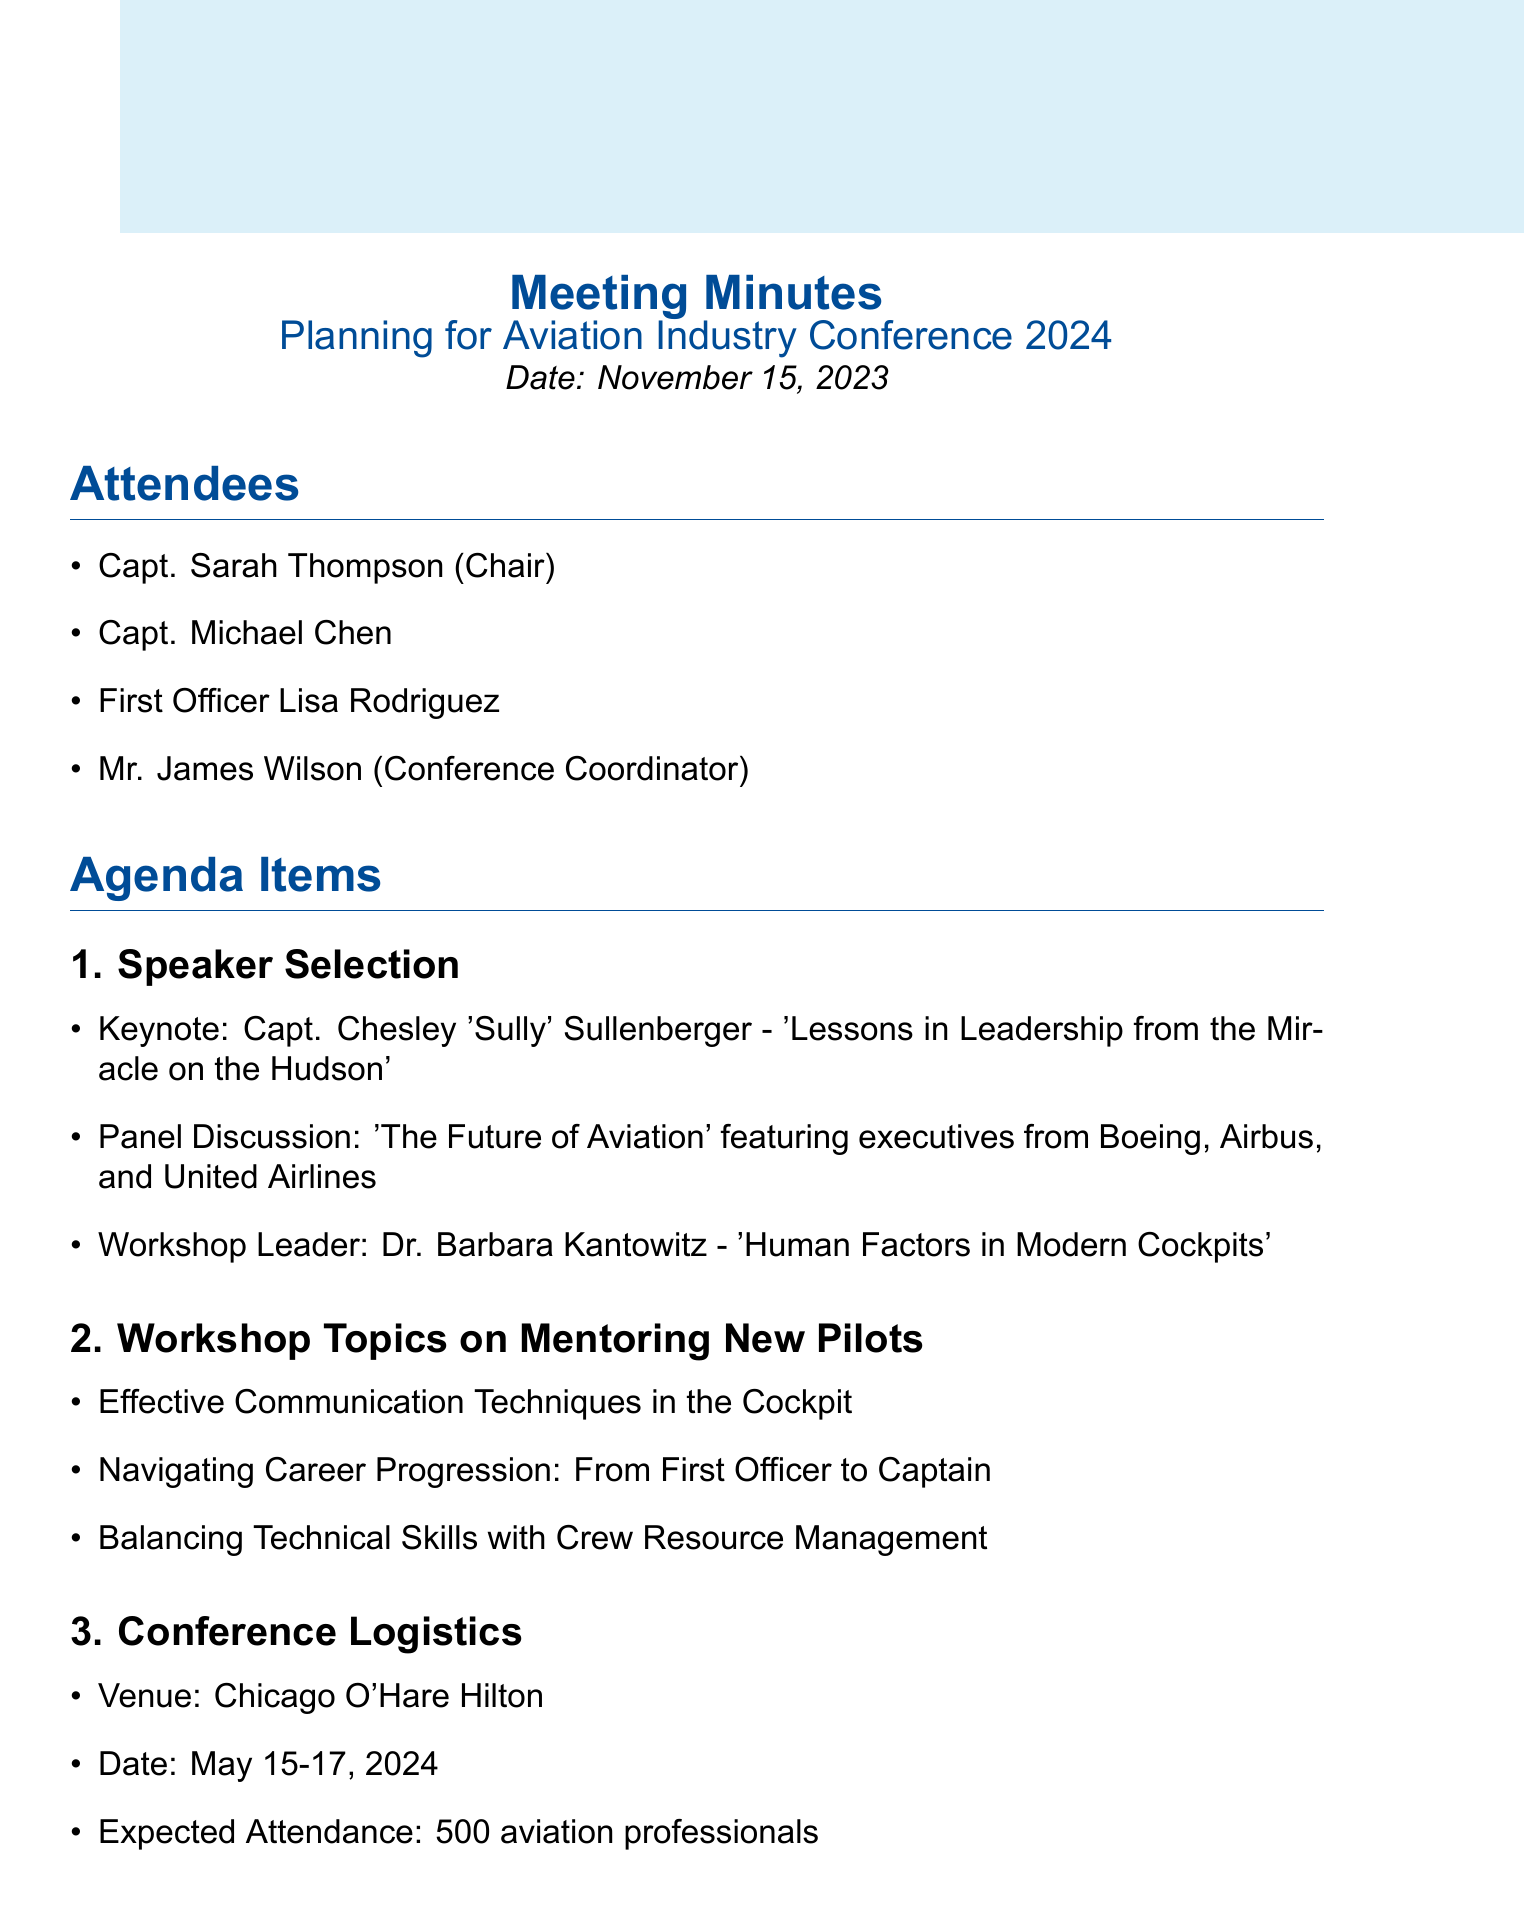What is the title of the meeting? The title of the meeting is stated in the document as "Planning for Aviation Industry Conference 2024."
Answer: Planning for Aviation Industry Conference 2024 Who is the keynote speaker? The keynote speaker is mentioned in the speaker selection section of the document as Capt. Chesley 'Sully' Sullenberger.
Answer: Capt. Chesley 'Sully' Sullenberger What are the dates of the conference? The dates of the conference are specified in the logistics section of the document as May 15-17, 2024.
Answer: May 15-17, 2024 How many expected attendees are there? The expected attendance is a specific detail found under conference logistics, stating the number of aviation professionals expected.
Answer: 500 aviation professionals What is the venue for the conference? The venue of the conference is listed in the conference logistics section as Chicago O'Hare Hilton.
Answer: Chicago O'Hare Hilton What workshop topic addresses communication techniques? The workshop topic that addresses communication techniques is mentioned in the mentoring section of the agenda items.
Answer: Effective Communication Techniques in the Cockpit Which action item involves reaching out to a keynote speaker's team? One action item includes Capt. Thompson reaching out to Capt. Sullenberger's team for confirmation of the keynote.
Answer: Capt. Thompson to reach out to Capt. Sullenberger's team for keynote confirmation When is the next meeting scheduled? The next meeting date is clearly stated at the end of the document.
Answer: December 1, 2023 